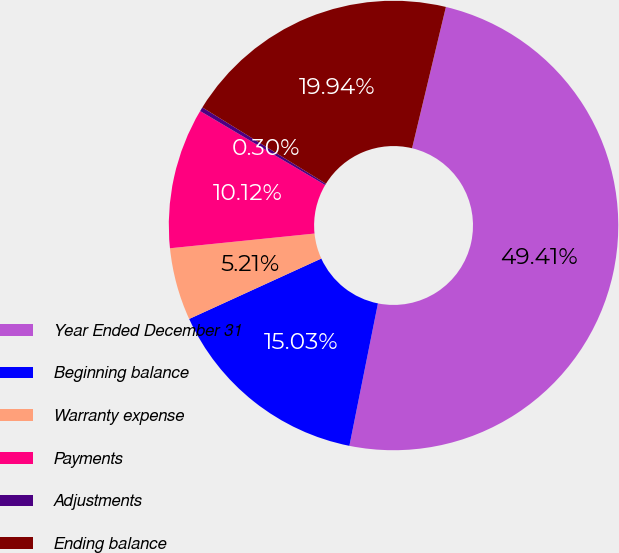Convert chart to OTSL. <chart><loc_0><loc_0><loc_500><loc_500><pie_chart><fcel>Year Ended December 31<fcel>Beginning balance<fcel>Warranty expense<fcel>Payments<fcel>Adjustments<fcel>Ending balance<nl><fcel>49.41%<fcel>15.03%<fcel>5.21%<fcel>10.12%<fcel>0.3%<fcel>19.94%<nl></chart> 